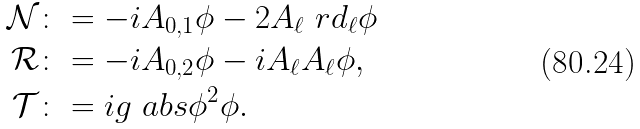<formula> <loc_0><loc_0><loc_500><loc_500>\mathcal { N } & \colon = - i A _ { 0 , 1 } \phi - 2 A _ { \ell } \ r d _ { \ell } \phi \\ \mathcal { R } & \colon = - i A _ { 0 , 2 } \phi - i A _ { \ell } A _ { \ell } \phi , \\ \mathcal { T } & \colon = i g \ a b s { \phi } ^ { 2 } \phi .</formula> 